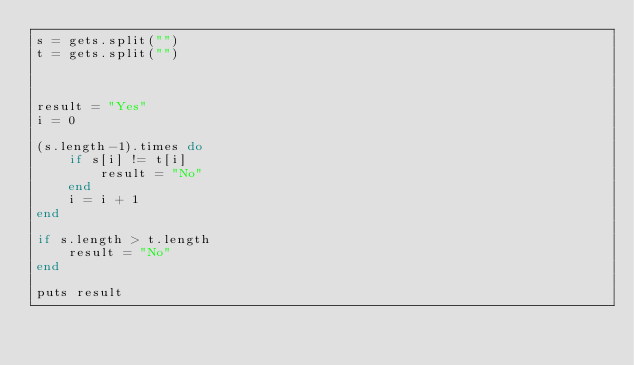Convert code to text. <code><loc_0><loc_0><loc_500><loc_500><_Ruby_>s = gets.split("")
t = gets.split("")



result = "Yes"
i = 0

(s.length-1).times do
    if s[i] != t[i]
        result = "No"
    end
    i = i + 1
end

if s.length > t.length
    result = "No"
end

puts result</code> 